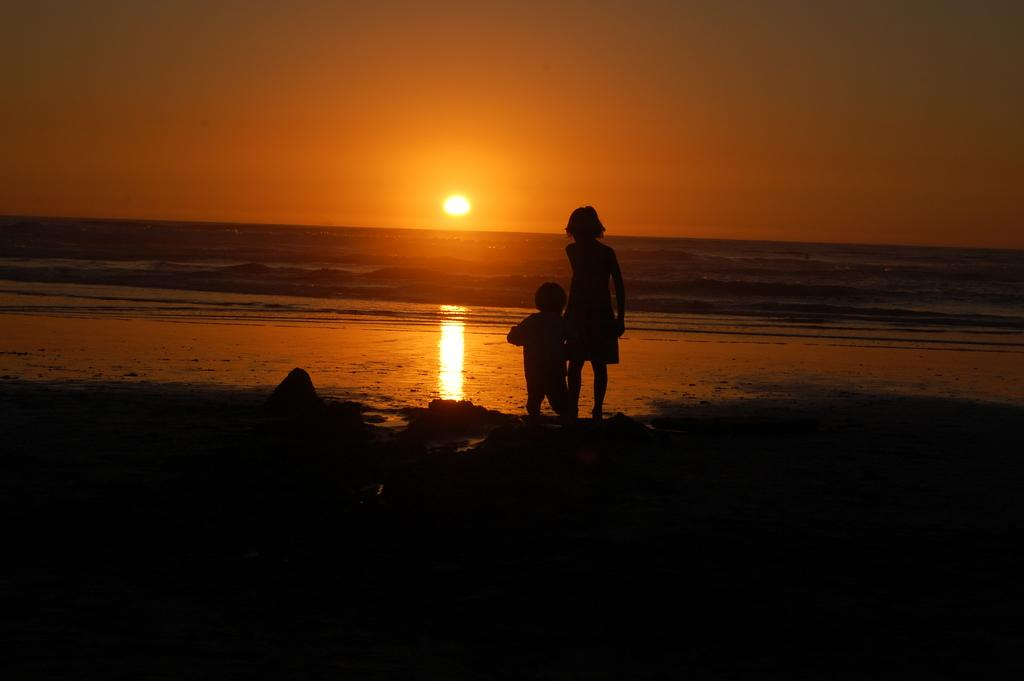Who is in the foreground of the picture? There is a girl and a kid in the foreground of the picture. What is the condition of the ground in the foreground? There is mud in the foreground of the picture. What can be seen in the middle of the picture? There appears to be a water body in the middle of the picture. What is the weather like in the image? The sun is shining in the sky in the background of the picture, indicating a sunny day. What type of parcel is being delivered to the girl in the image? There is no parcel visible in the image, and no indication of a delivery being made. Can you hear the servant's voice in the image? There is no servant or voice present in the image; it is a visual representation only. 